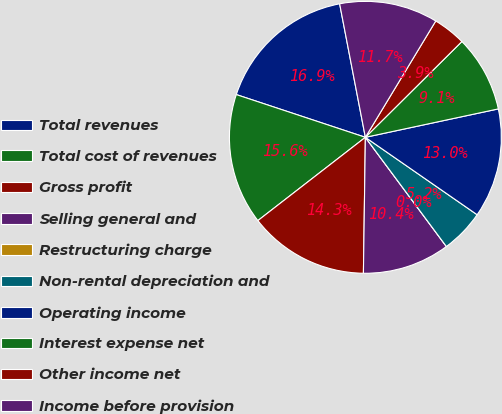<chart> <loc_0><loc_0><loc_500><loc_500><pie_chart><fcel>Total revenues<fcel>Total cost of revenues<fcel>Gross profit<fcel>Selling general and<fcel>Restructuring charge<fcel>Non-rental depreciation and<fcel>Operating income<fcel>Interest expense net<fcel>Other income net<fcel>Income before provision<nl><fcel>16.88%<fcel>15.58%<fcel>14.28%<fcel>10.39%<fcel>0.0%<fcel>5.2%<fcel>12.99%<fcel>9.09%<fcel>3.9%<fcel>11.69%<nl></chart> 